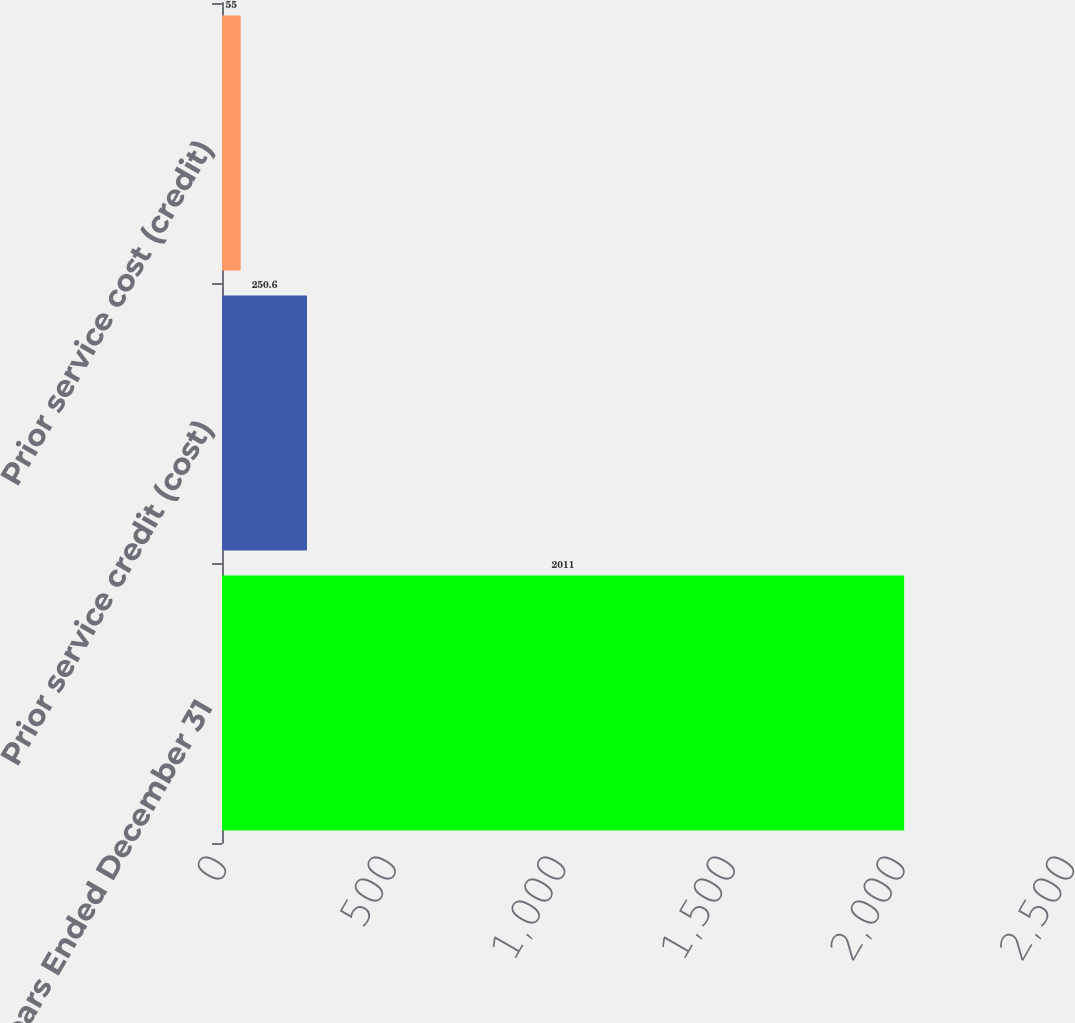Convert chart. <chart><loc_0><loc_0><loc_500><loc_500><bar_chart><fcel>Years Ended December 31<fcel>Prior service credit (cost)<fcel>Prior service cost (credit)<nl><fcel>2011<fcel>250.6<fcel>55<nl></chart> 